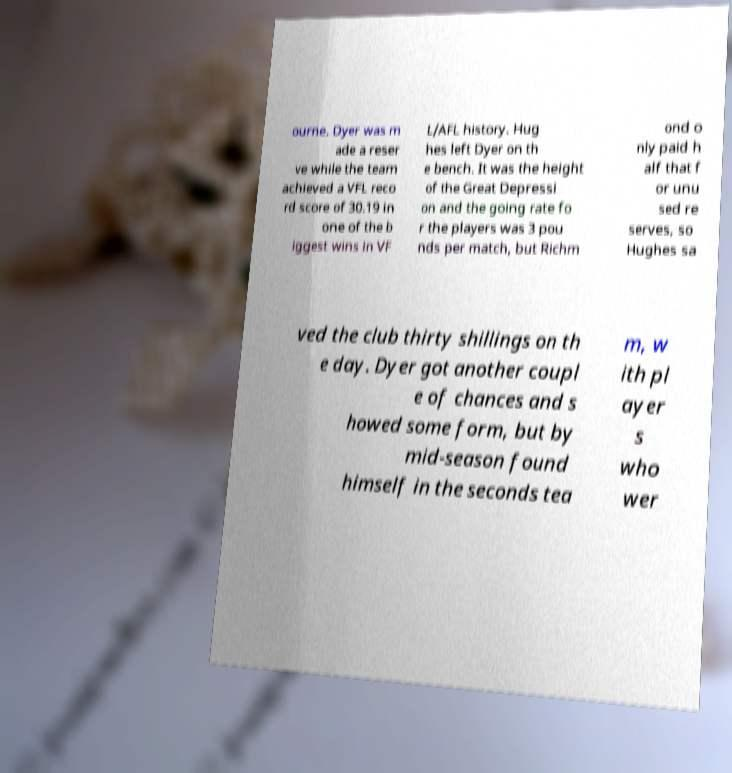Can you accurately transcribe the text from the provided image for me? ourne. Dyer was m ade a reser ve while the team achieved a VFL reco rd score of 30.19 in one of the b iggest wins in VF L/AFL history. Hug hes left Dyer on th e bench. It was the height of the Great Depressi on and the going rate fo r the players was 3 pou nds per match, but Richm ond o nly paid h alf that f or unu sed re serves, so Hughes sa ved the club thirty shillings on th e day. Dyer got another coupl e of chances and s howed some form, but by mid-season found himself in the seconds tea m, w ith pl ayer s who wer 